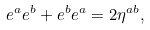Convert formula to latex. <formula><loc_0><loc_0><loc_500><loc_500>e ^ { a } e ^ { b } + e ^ { b } e ^ { a } = 2 \eta ^ { a b } ,</formula> 